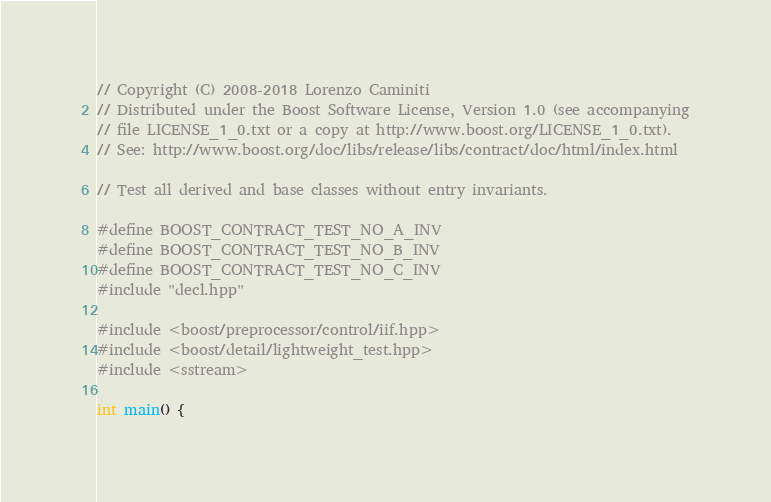<code> <loc_0><loc_0><loc_500><loc_500><_C++_>
// Copyright (C) 2008-2018 Lorenzo Caminiti
// Distributed under the Boost Software License, Version 1.0 (see accompanying
// file LICENSE_1_0.txt or a copy at http://www.boost.org/LICENSE_1_0.txt).
// See: http://www.boost.org/doc/libs/release/libs/contract/doc/html/index.html

// Test all derived and base classes without entry invariants.

#define BOOST_CONTRACT_TEST_NO_A_INV
#define BOOST_CONTRACT_TEST_NO_B_INV
#define BOOST_CONTRACT_TEST_NO_C_INV
#include "decl.hpp"

#include <boost/preprocessor/control/iif.hpp>
#include <boost/detail/lightweight_test.hpp>
#include <sstream>

int main() {</code> 